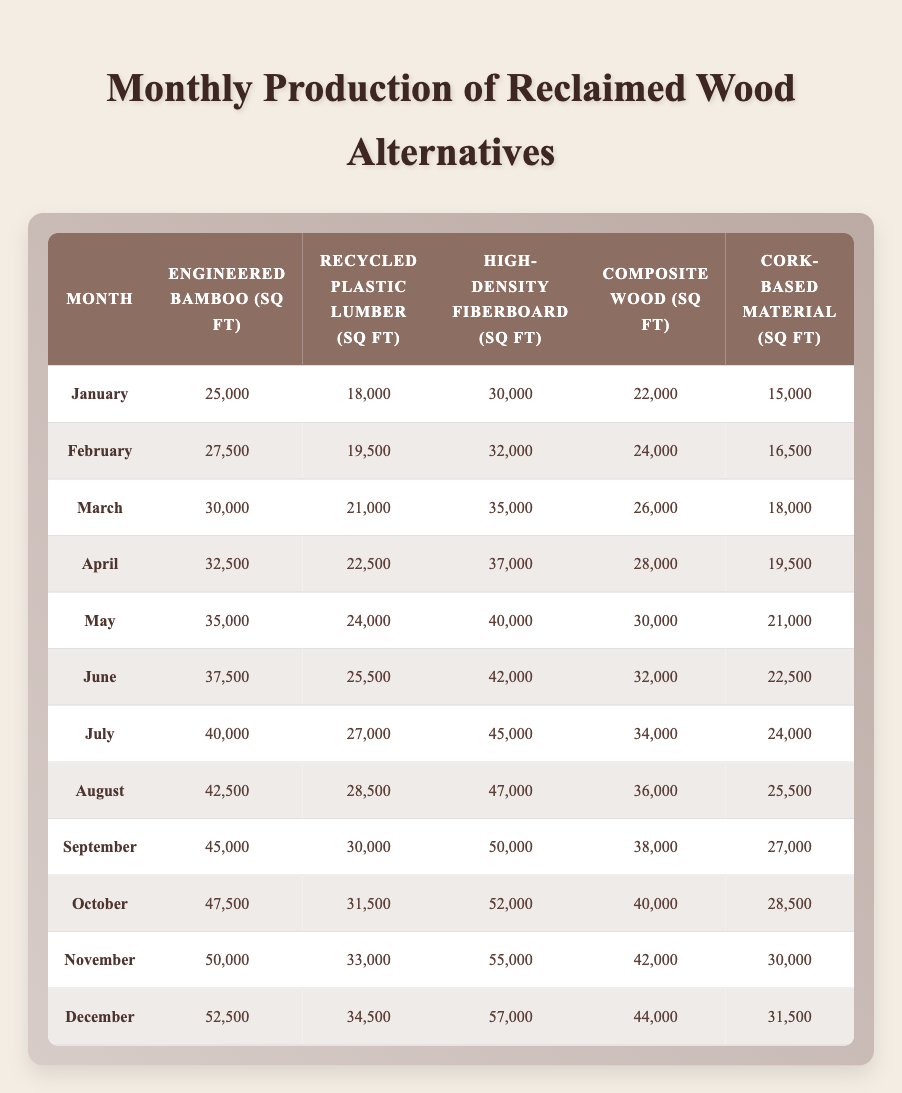What is the production output for engineered bamboo in October? The table specifies that in October, the production output of engineered bamboo is listed as 47,500 sq ft.
Answer: 47,500 sq ft Which month had the highest production of recycled plastic lumber? By examining the table, the highest production output for recycled plastic lumber occurs in December, which is 34,500 sq ft.
Answer: December What is the total output for composite wood over the entire year? To calculate this, I will add the monthly production values for composite wood: 22,000 + 24,000 + 26,000 + 28,000 + 30,000 + 32,000 + 34,000 + 36,000 + 38,000 + 40,000 + 42,000 + 44,000 =  400,000 sq ft. Thus, the total output for composite wood for the year is 400,000 sq ft.
Answer: 400,000 sq ft Is the production of high-density fiberboard greater in June than in February? According to the table, the production for high-density fiberboard in June is 42,000 sq ft, while in February it is 32,000 sq ft. Since 42,000 is greater than 32,000, the statement is true.
Answer: Yes What is the average monthly production output for cork-based material throughout the year? To find the average, I sum the monthly outputs for cork-based material: 15,000 + 16,500 + 18,000 + 19,500 + 21,000 + 22,500 + 24,000 + 25,500 + 27,000 + 28,500 + 30,000 + 31,500 =  300,000 sq ft. Now, divide by 12 months: 300,000 / 12 = 25,000 sq ft. Thus, the average monthly production output is 25,000 sq ft.
Answer: 25,000 sq ft Which material had the increased production percentage from January to July? For January, engineered bamboo produced 25,000 sq ft, and in July, it produced 40,000 sq ft. The increase is 40,000 - 25,000 = 15,000 sq ft. When we calculate the percentage increase, (15,000 / 25,000) * 100 = 60%. Thus, engineered bamboo experienced a 60% increase from January to July.
Answer: 60% 